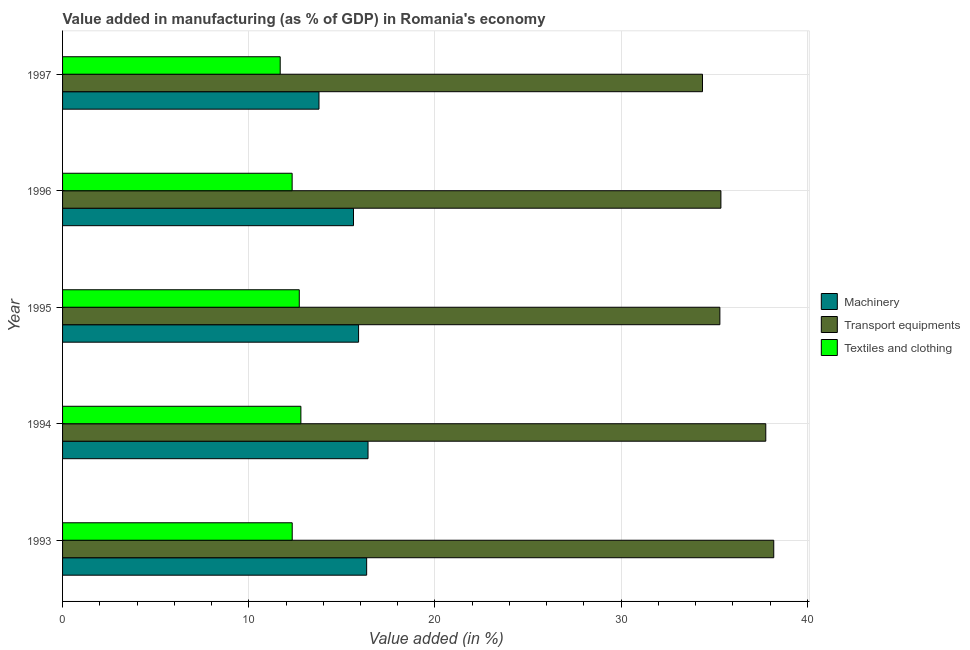Are the number of bars per tick equal to the number of legend labels?
Your answer should be very brief. Yes. How many bars are there on the 1st tick from the top?
Your answer should be compact. 3. How many bars are there on the 1st tick from the bottom?
Make the answer very short. 3. What is the label of the 3rd group of bars from the top?
Ensure brevity in your answer.  1995. In how many cases, is the number of bars for a given year not equal to the number of legend labels?
Your answer should be compact. 0. What is the value added in manufacturing textile and clothing in 1996?
Provide a succinct answer. 12.33. Across all years, what is the maximum value added in manufacturing textile and clothing?
Offer a very short reply. 12.8. Across all years, what is the minimum value added in manufacturing transport equipments?
Keep it short and to the point. 34.37. In which year was the value added in manufacturing textile and clothing minimum?
Ensure brevity in your answer.  1997. What is the total value added in manufacturing textile and clothing in the graph?
Offer a terse response. 61.86. What is the difference between the value added in manufacturing textile and clothing in 1994 and that in 1997?
Your answer should be compact. 1.11. What is the difference between the value added in manufacturing machinery in 1995 and the value added in manufacturing transport equipments in 1996?
Offer a terse response. -19.46. What is the average value added in manufacturing transport equipments per year?
Give a very brief answer. 36.2. In the year 1995, what is the difference between the value added in manufacturing textile and clothing and value added in manufacturing transport equipments?
Your response must be concise. -22.59. In how many years, is the value added in manufacturing transport equipments greater than 18 %?
Give a very brief answer. 5. What is the ratio of the value added in manufacturing transport equipments in 1994 to that in 1997?
Your answer should be compact. 1.1. Is the difference between the value added in manufacturing textile and clothing in 1994 and 1996 greater than the difference between the value added in manufacturing machinery in 1994 and 1996?
Your answer should be very brief. No. What is the difference between the highest and the second highest value added in manufacturing textile and clothing?
Provide a succinct answer. 0.09. What is the difference between the highest and the lowest value added in manufacturing machinery?
Provide a short and direct response. 2.63. In how many years, is the value added in manufacturing textile and clothing greater than the average value added in manufacturing textile and clothing taken over all years?
Offer a terse response. 2. Is the sum of the value added in manufacturing machinery in 1993 and 1996 greater than the maximum value added in manufacturing textile and clothing across all years?
Offer a very short reply. Yes. What does the 2nd bar from the top in 1997 represents?
Your response must be concise. Transport equipments. What does the 3rd bar from the bottom in 1997 represents?
Ensure brevity in your answer.  Textiles and clothing. How many bars are there?
Give a very brief answer. 15. How many years are there in the graph?
Provide a short and direct response. 5. What is the difference between two consecutive major ticks on the X-axis?
Offer a very short reply. 10. Are the values on the major ticks of X-axis written in scientific E-notation?
Provide a short and direct response. No. Does the graph contain any zero values?
Keep it short and to the point. No. Where does the legend appear in the graph?
Provide a short and direct response. Center right. How many legend labels are there?
Provide a succinct answer. 3. How are the legend labels stacked?
Your response must be concise. Vertical. What is the title of the graph?
Keep it short and to the point. Value added in manufacturing (as % of GDP) in Romania's economy. What is the label or title of the X-axis?
Your answer should be compact. Value added (in %). What is the Value added (in %) in Machinery in 1993?
Offer a terse response. 16.33. What is the Value added (in %) in Transport equipments in 1993?
Your answer should be very brief. 38.19. What is the Value added (in %) of Textiles and clothing in 1993?
Offer a very short reply. 12.33. What is the Value added (in %) in Machinery in 1994?
Offer a very short reply. 16.4. What is the Value added (in %) in Transport equipments in 1994?
Ensure brevity in your answer.  37.77. What is the Value added (in %) in Textiles and clothing in 1994?
Make the answer very short. 12.8. What is the Value added (in %) in Machinery in 1995?
Keep it short and to the point. 15.9. What is the Value added (in %) of Transport equipments in 1995?
Your response must be concise. 35.3. What is the Value added (in %) of Textiles and clothing in 1995?
Your answer should be compact. 12.71. What is the Value added (in %) of Machinery in 1996?
Give a very brief answer. 15.62. What is the Value added (in %) of Transport equipments in 1996?
Make the answer very short. 35.36. What is the Value added (in %) in Textiles and clothing in 1996?
Provide a short and direct response. 12.33. What is the Value added (in %) of Machinery in 1997?
Your answer should be very brief. 13.77. What is the Value added (in %) in Transport equipments in 1997?
Provide a succinct answer. 34.37. What is the Value added (in %) in Textiles and clothing in 1997?
Give a very brief answer. 11.69. Across all years, what is the maximum Value added (in %) of Machinery?
Your response must be concise. 16.4. Across all years, what is the maximum Value added (in %) in Transport equipments?
Keep it short and to the point. 38.19. Across all years, what is the maximum Value added (in %) in Textiles and clothing?
Offer a very short reply. 12.8. Across all years, what is the minimum Value added (in %) of Machinery?
Give a very brief answer. 13.77. Across all years, what is the minimum Value added (in %) in Transport equipments?
Make the answer very short. 34.37. Across all years, what is the minimum Value added (in %) of Textiles and clothing?
Your answer should be compact. 11.69. What is the total Value added (in %) of Machinery in the graph?
Your answer should be very brief. 78.03. What is the total Value added (in %) in Transport equipments in the graph?
Keep it short and to the point. 180.98. What is the total Value added (in %) of Textiles and clothing in the graph?
Give a very brief answer. 61.86. What is the difference between the Value added (in %) in Machinery in 1993 and that in 1994?
Provide a succinct answer. -0.07. What is the difference between the Value added (in %) in Transport equipments in 1993 and that in 1994?
Your answer should be compact. 0.43. What is the difference between the Value added (in %) in Textiles and clothing in 1993 and that in 1994?
Offer a terse response. -0.47. What is the difference between the Value added (in %) of Machinery in 1993 and that in 1995?
Provide a succinct answer. 0.43. What is the difference between the Value added (in %) of Transport equipments in 1993 and that in 1995?
Provide a short and direct response. 2.89. What is the difference between the Value added (in %) in Textiles and clothing in 1993 and that in 1995?
Make the answer very short. -0.38. What is the difference between the Value added (in %) of Machinery in 1993 and that in 1996?
Provide a short and direct response. 0.71. What is the difference between the Value added (in %) in Transport equipments in 1993 and that in 1996?
Your response must be concise. 2.84. What is the difference between the Value added (in %) of Textiles and clothing in 1993 and that in 1996?
Provide a succinct answer. 0. What is the difference between the Value added (in %) in Machinery in 1993 and that in 1997?
Keep it short and to the point. 2.56. What is the difference between the Value added (in %) of Transport equipments in 1993 and that in 1997?
Give a very brief answer. 3.83. What is the difference between the Value added (in %) in Textiles and clothing in 1993 and that in 1997?
Give a very brief answer. 0.65. What is the difference between the Value added (in %) in Machinery in 1994 and that in 1995?
Your answer should be compact. 0.51. What is the difference between the Value added (in %) in Transport equipments in 1994 and that in 1995?
Offer a terse response. 2.46. What is the difference between the Value added (in %) in Textiles and clothing in 1994 and that in 1995?
Provide a short and direct response. 0.09. What is the difference between the Value added (in %) of Machinery in 1994 and that in 1996?
Offer a terse response. 0.78. What is the difference between the Value added (in %) in Transport equipments in 1994 and that in 1996?
Provide a succinct answer. 2.41. What is the difference between the Value added (in %) of Textiles and clothing in 1994 and that in 1996?
Provide a short and direct response. 0.47. What is the difference between the Value added (in %) of Machinery in 1994 and that in 1997?
Ensure brevity in your answer.  2.63. What is the difference between the Value added (in %) of Transport equipments in 1994 and that in 1997?
Provide a succinct answer. 3.4. What is the difference between the Value added (in %) of Textiles and clothing in 1994 and that in 1997?
Your response must be concise. 1.11. What is the difference between the Value added (in %) of Machinery in 1995 and that in 1996?
Offer a very short reply. 0.27. What is the difference between the Value added (in %) of Transport equipments in 1995 and that in 1996?
Your answer should be very brief. -0.06. What is the difference between the Value added (in %) of Textiles and clothing in 1995 and that in 1996?
Provide a short and direct response. 0.38. What is the difference between the Value added (in %) of Machinery in 1995 and that in 1997?
Make the answer very short. 2.13. What is the difference between the Value added (in %) in Transport equipments in 1995 and that in 1997?
Offer a terse response. 0.93. What is the difference between the Value added (in %) in Textiles and clothing in 1995 and that in 1997?
Offer a very short reply. 1.02. What is the difference between the Value added (in %) in Machinery in 1996 and that in 1997?
Your answer should be compact. 1.85. What is the difference between the Value added (in %) in Transport equipments in 1996 and that in 1997?
Offer a terse response. 0.99. What is the difference between the Value added (in %) in Textiles and clothing in 1996 and that in 1997?
Make the answer very short. 0.64. What is the difference between the Value added (in %) in Machinery in 1993 and the Value added (in %) in Transport equipments in 1994?
Ensure brevity in your answer.  -21.43. What is the difference between the Value added (in %) of Machinery in 1993 and the Value added (in %) of Textiles and clothing in 1994?
Ensure brevity in your answer.  3.53. What is the difference between the Value added (in %) of Transport equipments in 1993 and the Value added (in %) of Textiles and clothing in 1994?
Keep it short and to the point. 25.39. What is the difference between the Value added (in %) of Machinery in 1993 and the Value added (in %) of Transport equipments in 1995?
Make the answer very short. -18.97. What is the difference between the Value added (in %) of Machinery in 1993 and the Value added (in %) of Textiles and clothing in 1995?
Make the answer very short. 3.62. What is the difference between the Value added (in %) of Transport equipments in 1993 and the Value added (in %) of Textiles and clothing in 1995?
Your answer should be very brief. 25.48. What is the difference between the Value added (in %) in Machinery in 1993 and the Value added (in %) in Transport equipments in 1996?
Ensure brevity in your answer.  -19.02. What is the difference between the Value added (in %) in Machinery in 1993 and the Value added (in %) in Textiles and clothing in 1996?
Keep it short and to the point. 4. What is the difference between the Value added (in %) in Transport equipments in 1993 and the Value added (in %) in Textiles and clothing in 1996?
Offer a very short reply. 25.86. What is the difference between the Value added (in %) of Machinery in 1993 and the Value added (in %) of Transport equipments in 1997?
Make the answer very short. -18.04. What is the difference between the Value added (in %) of Machinery in 1993 and the Value added (in %) of Textiles and clothing in 1997?
Keep it short and to the point. 4.64. What is the difference between the Value added (in %) of Transport equipments in 1993 and the Value added (in %) of Textiles and clothing in 1997?
Your response must be concise. 26.51. What is the difference between the Value added (in %) in Machinery in 1994 and the Value added (in %) in Transport equipments in 1995?
Your response must be concise. -18.9. What is the difference between the Value added (in %) in Machinery in 1994 and the Value added (in %) in Textiles and clothing in 1995?
Ensure brevity in your answer.  3.69. What is the difference between the Value added (in %) in Transport equipments in 1994 and the Value added (in %) in Textiles and clothing in 1995?
Provide a succinct answer. 25.05. What is the difference between the Value added (in %) of Machinery in 1994 and the Value added (in %) of Transport equipments in 1996?
Give a very brief answer. -18.95. What is the difference between the Value added (in %) of Machinery in 1994 and the Value added (in %) of Textiles and clothing in 1996?
Offer a very short reply. 4.08. What is the difference between the Value added (in %) of Transport equipments in 1994 and the Value added (in %) of Textiles and clothing in 1996?
Your response must be concise. 25.44. What is the difference between the Value added (in %) in Machinery in 1994 and the Value added (in %) in Transport equipments in 1997?
Ensure brevity in your answer.  -17.96. What is the difference between the Value added (in %) in Machinery in 1994 and the Value added (in %) in Textiles and clothing in 1997?
Give a very brief answer. 4.72. What is the difference between the Value added (in %) in Transport equipments in 1994 and the Value added (in %) in Textiles and clothing in 1997?
Ensure brevity in your answer.  26.08. What is the difference between the Value added (in %) of Machinery in 1995 and the Value added (in %) of Transport equipments in 1996?
Your answer should be very brief. -19.46. What is the difference between the Value added (in %) of Machinery in 1995 and the Value added (in %) of Textiles and clothing in 1996?
Offer a terse response. 3.57. What is the difference between the Value added (in %) of Transport equipments in 1995 and the Value added (in %) of Textiles and clothing in 1996?
Make the answer very short. 22.97. What is the difference between the Value added (in %) in Machinery in 1995 and the Value added (in %) in Transport equipments in 1997?
Your answer should be compact. -18.47. What is the difference between the Value added (in %) in Machinery in 1995 and the Value added (in %) in Textiles and clothing in 1997?
Provide a succinct answer. 4.21. What is the difference between the Value added (in %) of Transport equipments in 1995 and the Value added (in %) of Textiles and clothing in 1997?
Make the answer very short. 23.61. What is the difference between the Value added (in %) in Machinery in 1996 and the Value added (in %) in Transport equipments in 1997?
Your answer should be very brief. -18.74. What is the difference between the Value added (in %) in Machinery in 1996 and the Value added (in %) in Textiles and clothing in 1997?
Your answer should be compact. 3.94. What is the difference between the Value added (in %) of Transport equipments in 1996 and the Value added (in %) of Textiles and clothing in 1997?
Give a very brief answer. 23.67. What is the average Value added (in %) of Machinery per year?
Provide a short and direct response. 15.61. What is the average Value added (in %) in Transport equipments per year?
Your answer should be compact. 36.2. What is the average Value added (in %) of Textiles and clothing per year?
Ensure brevity in your answer.  12.37. In the year 1993, what is the difference between the Value added (in %) in Machinery and Value added (in %) in Transport equipments?
Offer a very short reply. -21.86. In the year 1993, what is the difference between the Value added (in %) of Machinery and Value added (in %) of Textiles and clothing?
Your response must be concise. 4. In the year 1993, what is the difference between the Value added (in %) of Transport equipments and Value added (in %) of Textiles and clothing?
Your answer should be very brief. 25.86. In the year 1994, what is the difference between the Value added (in %) in Machinery and Value added (in %) in Transport equipments?
Ensure brevity in your answer.  -21.36. In the year 1994, what is the difference between the Value added (in %) of Machinery and Value added (in %) of Textiles and clothing?
Your answer should be very brief. 3.61. In the year 1994, what is the difference between the Value added (in %) of Transport equipments and Value added (in %) of Textiles and clothing?
Make the answer very short. 24.97. In the year 1995, what is the difference between the Value added (in %) in Machinery and Value added (in %) in Transport equipments?
Offer a very short reply. -19.4. In the year 1995, what is the difference between the Value added (in %) of Machinery and Value added (in %) of Textiles and clothing?
Give a very brief answer. 3.18. In the year 1995, what is the difference between the Value added (in %) in Transport equipments and Value added (in %) in Textiles and clothing?
Make the answer very short. 22.59. In the year 1996, what is the difference between the Value added (in %) in Machinery and Value added (in %) in Transport equipments?
Provide a short and direct response. -19.73. In the year 1996, what is the difference between the Value added (in %) in Machinery and Value added (in %) in Textiles and clothing?
Offer a very short reply. 3.29. In the year 1996, what is the difference between the Value added (in %) in Transport equipments and Value added (in %) in Textiles and clothing?
Provide a short and direct response. 23.03. In the year 1997, what is the difference between the Value added (in %) of Machinery and Value added (in %) of Transport equipments?
Make the answer very short. -20.6. In the year 1997, what is the difference between the Value added (in %) of Machinery and Value added (in %) of Textiles and clothing?
Give a very brief answer. 2.08. In the year 1997, what is the difference between the Value added (in %) in Transport equipments and Value added (in %) in Textiles and clothing?
Your answer should be very brief. 22.68. What is the ratio of the Value added (in %) of Machinery in 1993 to that in 1994?
Offer a terse response. 1. What is the ratio of the Value added (in %) in Transport equipments in 1993 to that in 1994?
Provide a short and direct response. 1.01. What is the ratio of the Value added (in %) of Textiles and clothing in 1993 to that in 1994?
Make the answer very short. 0.96. What is the ratio of the Value added (in %) of Machinery in 1993 to that in 1995?
Your answer should be compact. 1.03. What is the ratio of the Value added (in %) in Transport equipments in 1993 to that in 1995?
Your answer should be compact. 1.08. What is the ratio of the Value added (in %) in Textiles and clothing in 1993 to that in 1995?
Your answer should be compact. 0.97. What is the ratio of the Value added (in %) in Machinery in 1993 to that in 1996?
Keep it short and to the point. 1.05. What is the ratio of the Value added (in %) in Transport equipments in 1993 to that in 1996?
Offer a terse response. 1.08. What is the ratio of the Value added (in %) in Machinery in 1993 to that in 1997?
Your answer should be very brief. 1.19. What is the ratio of the Value added (in %) of Transport equipments in 1993 to that in 1997?
Keep it short and to the point. 1.11. What is the ratio of the Value added (in %) of Textiles and clothing in 1993 to that in 1997?
Provide a succinct answer. 1.06. What is the ratio of the Value added (in %) of Machinery in 1994 to that in 1995?
Your answer should be very brief. 1.03. What is the ratio of the Value added (in %) of Transport equipments in 1994 to that in 1995?
Provide a succinct answer. 1.07. What is the ratio of the Value added (in %) of Machinery in 1994 to that in 1996?
Offer a terse response. 1.05. What is the ratio of the Value added (in %) in Transport equipments in 1994 to that in 1996?
Your answer should be compact. 1.07. What is the ratio of the Value added (in %) in Textiles and clothing in 1994 to that in 1996?
Keep it short and to the point. 1.04. What is the ratio of the Value added (in %) of Machinery in 1994 to that in 1997?
Keep it short and to the point. 1.19. What is the ratio of the Value added (in %) in Transport equipments in 1994 to that in 1997?
Ensure brevity in your answer.  1.1. What is the ratio of the Value added (in %) in Textiles and clothing in 1994 to that in 1997?
Provide a short and direct response. 1.1. What is the ratio of the Value added (in %) in Machinery in 1995 to that in 1996?
Provide a short and direct response. 1.02. What is the ratio of the Value added (in %) of Transport equipments in 1995 to that in 1996?
Your response must be concise. 1. What is the ratio of the Value added (in %) of Textiles and clothing in 1995 to that in 1996?
Offer a very short reply. 1.03. What is the ratio of the Value added (in %) of Machinery in 1995 to that in 1997?
Offer a very short reply. 1.15. What is the ratio of the Value added (in %) in Transport equipments in 1995 to that in 1997?
Ensure brevity in your answer.  1.03. What is the ratio of the Value added (in %) of Textiles and clothing in 1995 to that in 1997?
Make the answer very short. 1.09. What is the ratio of the Value added (in %) of Machinery in 1996 to that in 1997?
Your response must be concise. 1.13. What is the ratio of the Value added (in %) in Transport equipments in 1996 to that in 1997?
Ensure brevity in your answer.  1.03. What is the ratio of the Value added (in %) of Textiles and clothing in 1996 to that in 1997?
Provide a succinct answer. 1.05. What is the difference between the highest and the second highest Value added (in %) in Machinery?
Your answer should be very brief. 0.07. What is the difference between the highest and the second highest Value added (in %) in Transport equipments?
Provide a succinct answer. 0.43. What is the difference between the highest and the second highest Value added (in %) in Textiles and clothing?
Ensure brevity in your answer.  0.09. What is the difference between the highest and the lowest Value added (in %) in Machinery?
Your answer should be very brief. 2.63. What is the difference between the highest and the lowest Value added (in %) of Transport equipments?
Offer a very short reply. 3.83. What is the difference between the highest and the lowest Value added (in %) of Textiles and clothing?
Your answer should be very brief. 1.11. 